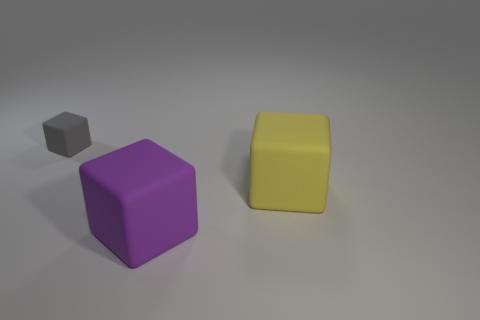Subtract all gray rubber blocks. How many blocks are left? 2 Subtract 0 brown cubes. How many objects are left? 3 Subtract all red cubes. Subtract all gray cylinders. How many cubes are left? 3 Subtract all purple balls. How many brown blocks are left? 0 Subtract all big yellow cubes. Subtract all purple rubber blocks. How many objects are left? 1 Add 3 rubber things. How many rubber things are left? 6 Add 2 rubber cubes. How many rubber cubes exist? 5 Add 3 large yellow matte blocks. How many objects exist? 6 Subtract all purple blocks. How many blocks are left? 2 